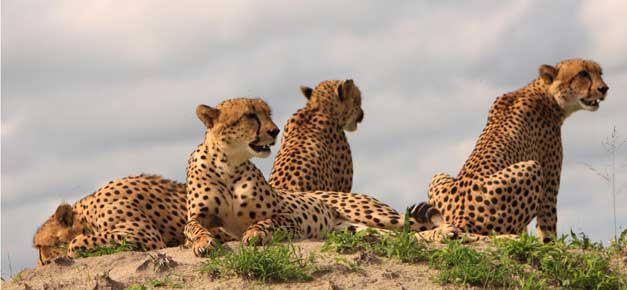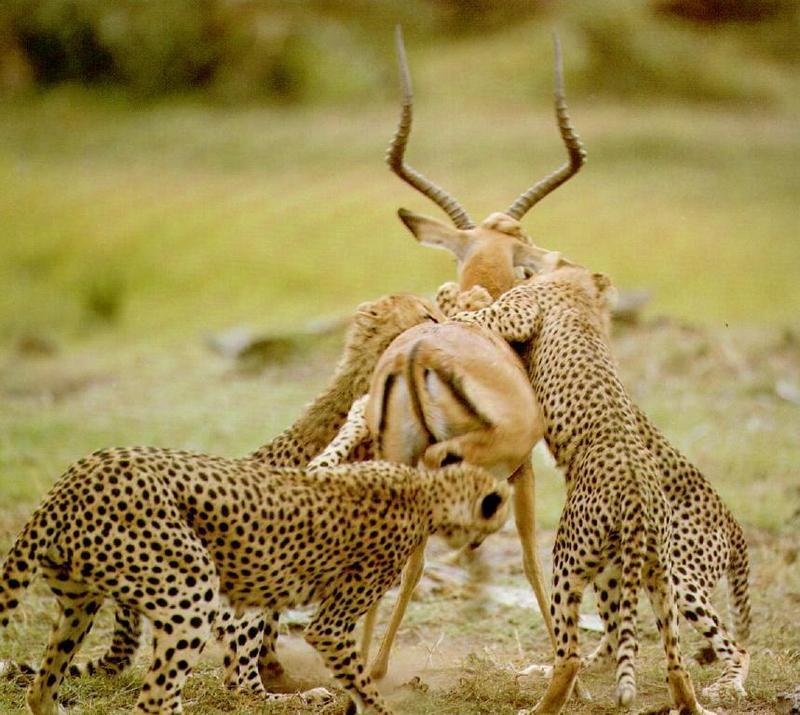The first image is the image on the left, the second image is the image on the right. Analyze the images presented: Is the assertion "There are no more than two cheetahs in the right image." valid? Answer yes or no. No. The first image is the image on the left, the second image is the image on the right. Examine the images to the left and right. Is the description "There are no more than 2 cheetas in the right image." accurate? Answer yes or no. No. The first image is the image on the left, the second image is the image on the right. Considering the images on both sides, is "An image shows one cheetah bounding with front paws extended." valid? Answer yes or no. No. The first image is the image on the left, the second image is the image on the right. Considering the images on both sides, is "There are four cheetas shown" valid? Answer yes or no. No. The first image is the image on the left, the second image is the image on the right. Assess this claim about the two images: "One of the large cats is biting an antelope.". Correct or not? Answer yes or no. Yes. 